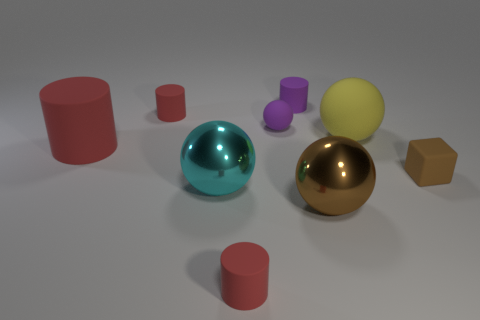Are there any cyan metallic objects that have the same shape as the brown shiny object?
Provide a succinct answer. Yes. How many other things are the same size as the yellow object?
Make the answer very short. 3. There is a matte cylinder that is on the right side of the cylinder that is in front of the cube; how big is it?
Make the answer very short. Small. How many large things are either metallic balls or purple rubber balls?
Ensure brevity in your answer.  2. How big is the rubber cylinder that is behind the small cylinder left of the red rubber cylinder in front of the brown sphere?
Provide a succinct answer. Small. Is there anything else that has the same color as the tiny ball?
Offer a terse response. Yes. There is a cylinder that is behind the small red matte thing that is left of the cylinder that is in front of the large cyan object; what is its material?
Make the answer very short. Rubber. Is the big brown metallic thing the same shape as the large cyan metallic object?
Your answer should be compact. Yes. What number of big rubber things are both on the right side of the big brown shiny object and in front of the large yellow sphere?
Make the answer very short. 0. There is a big rubber thing to the left of the red object that is behind the tiny purple sphere; what is its color?
Offer a very short reply. Red. 